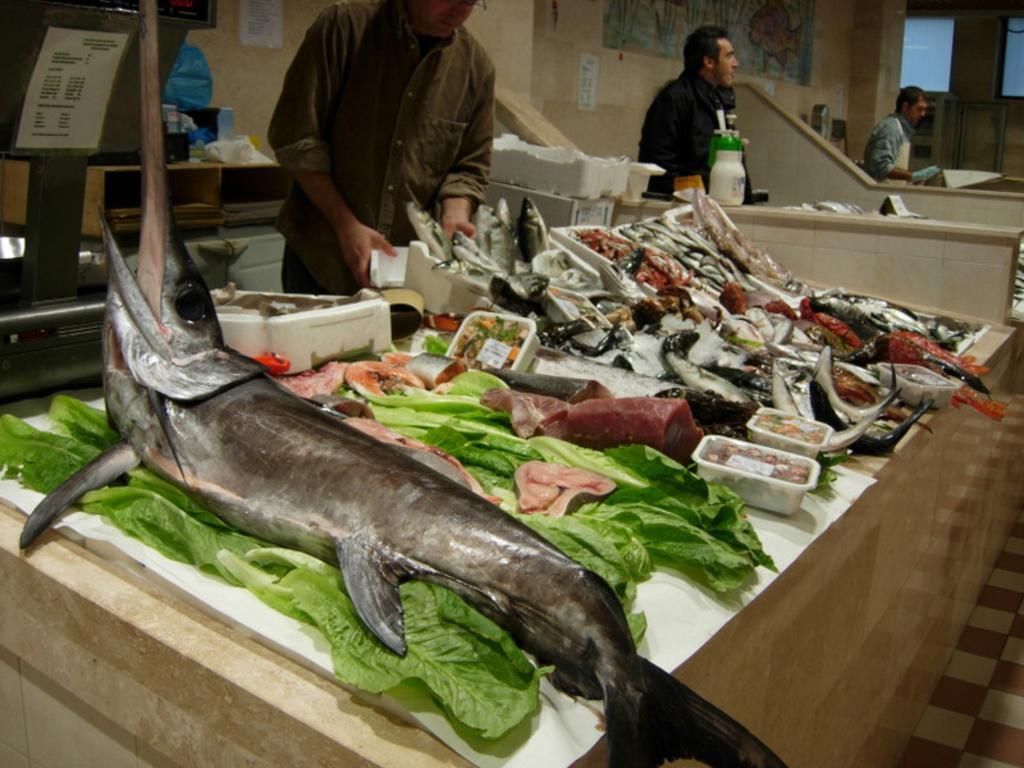Describe this image in one or two sentences. In this image we can see some people standing. One person is holding a object with his hand. In the foreground we can see some fish ,some containers with food and leaves placed on the surface. In the left side of the image we can see some boxes placed on the floor , poster with some text. In the background, we can see a bottle placed on the surface , painting on the wall , a door and windows. 